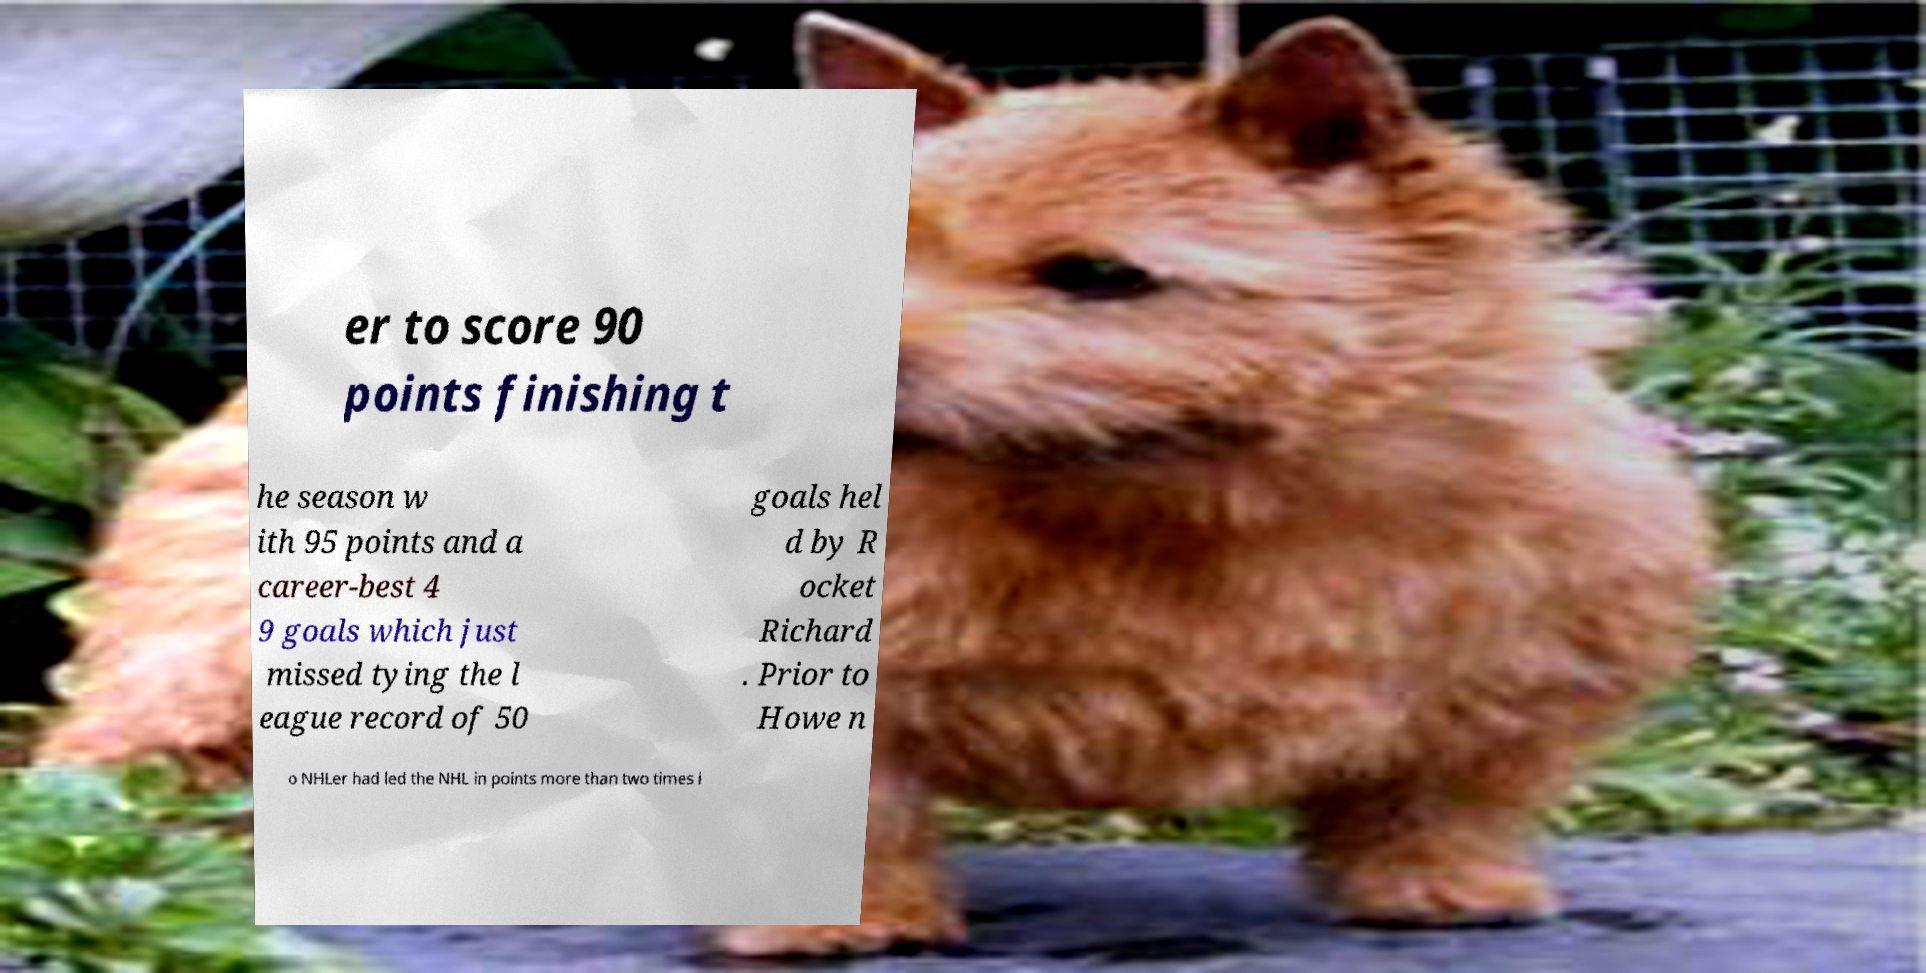There's text embedded in this image that I need extracted. Can you transcribe it verbatim? er to score 90 points finishing t he season w ith 95 points and a career-best 4 9 goals which just missed tying the l eague record of 50 goals hel d by R ocket Richard . Prior to Howe n o NHLer had led the NHL in points more than two times i 